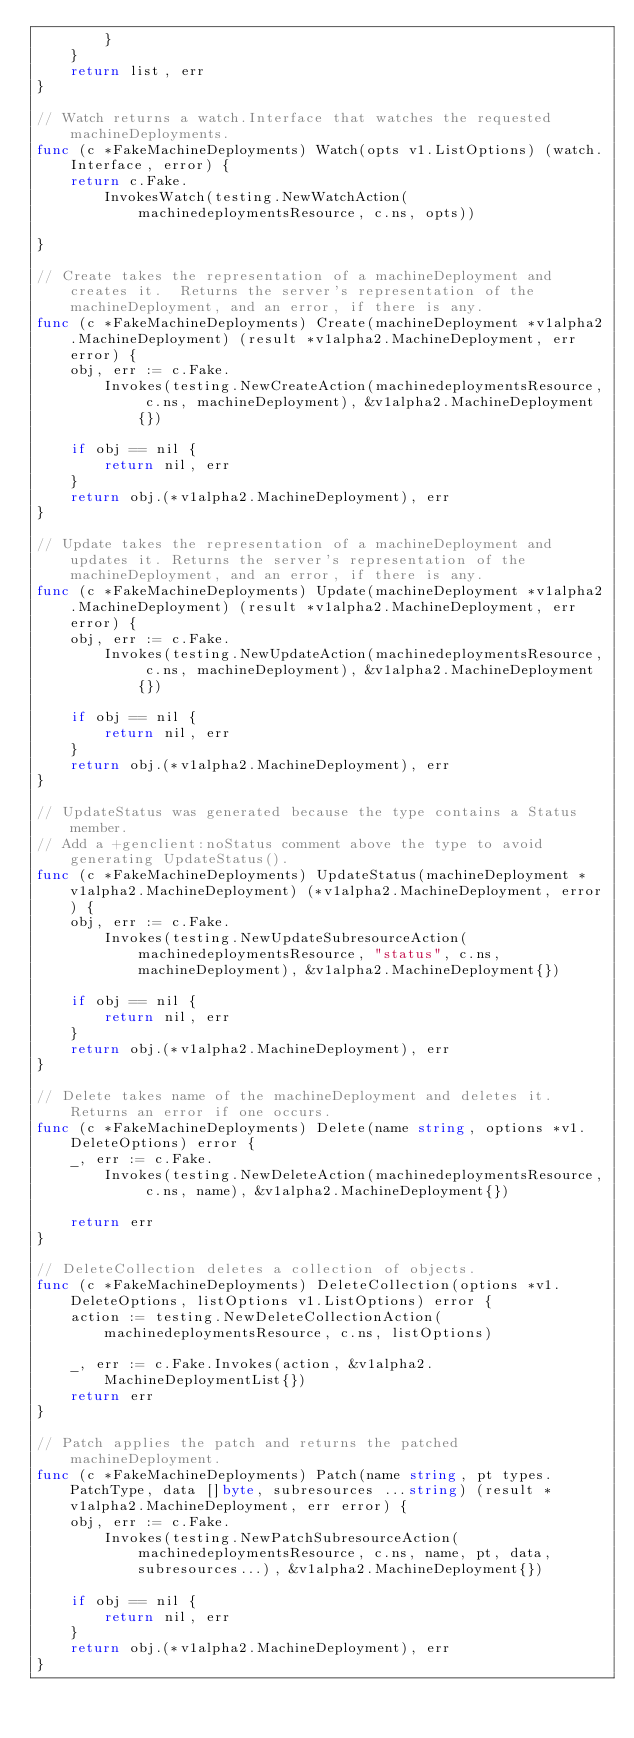Convert code to text. <code><loc_0><loc_0><loc_500><loc_500><_Go_>		}
	}
	return list, err
}

// Watch returns a watch.Interface that watches the requested machineDeployments.
func (c *FakeMachineDeployments) Watch(opts v1.ListOptions) (watch.Interface, error) {
	return c.Fake.
		InvokesWatch(testing.NewWatchAction(machinedeploymentsResource, c.ns, opts))

}

// Create takes the representation of a machineDeployment and creates it.  Returns the server's representation of the machineDeployment, and an error, if there is any.
func (c *FakeMachineDeployments) Create(machineDeployment *v1alpha2.MachineDeployment) (result *v1alpha2.MachineDeployment, err error) {
	obj, err := c.Fake.
		Invokes(testing.NewCreateAction(machinedeploymentsResource, c.ns, machineDeployment), &v1alpha2.MachineDeployment{})

	if obj == nil {
		return nil, err
	}
	return obj.(*v1alpha2.MachineDeployment), err
}

// Update takes the representation of a machineDeployment and updates it. Returns the server's representation of the machineDeployment, and an error, if there is any.
func (c *FakeMachineDeployments) Update(machineDeployment *v1alpha2.MachineDeployment) (result *v1alpha2.MachineDeployment, err error) {
	obj, err := c.Fake.
		Invokes(testing.NewUpdateAction(machinedeploymentsResource, c.ns, machineDeployment), &v1alpha2.MachineDeployment{})

	if obj == nil {
		return nil, err
	}
	return obj.(*v1alpha2.MachineDeployment), err
}

// UpdateStatus was generated because the type contains a Status member.
// Add a +genclient:noStatus comment above the type to avoid generating UpdateStatus().
func (c *FakeMachineDeployments) UpdateStatus(machineDeployment *v1alpha2.MachineDeployment) (*v1alpha2.MachineDeployment, error) {
	obj, err := c.Fake.
		Invokes(testing.NewUpdateSubresourceAction(machinedeploymentsResource, "status", c.ns, machineDeployment), &v1alpha2.MachineDeployment{})

	if obj == nil {
		return nil, err
	}
	return obj.(*v1alpha2.MachineDeployment), err
}

// Delete takes name of the machineDeployment and deletes it. Returns an error if one occurs.
func (c *FakeMachineDeployments) Delete(name string, options *v1.DeleteOptions) error {
	_, err := c.Fake.
		Invokes(testing.NewDeleteAction(machinedeploymentsResource, c.ns, name), &v1alpha2.MachineDeployment{})

	return err
}

// DeleteCollection deletes a collection of objects.
func (c *FakeMachineDeployments) DeleteCollection(options *v1.DeleteOptions, listOptions v1.ListOptions) error {
	action := testing.NewDeleteCollectionAction(machinedeploymentsResource, c.ns, listOptions)

	_, err := c.Fake.Invokes(action, &v1alpha2.MachineDeploymentList{})
	return err
}

// Patch applies the patch and returns the patched machineDeployment.
func (c *FakeMachineDeployments) Patch(name string, pt types.PatchType, data []byte, subresources ...string) (result *v1alpha2.MachineDeployment, err error) {
	obj, err := c.Fake.
		Invokes(testing.NewPatchSubresourceAction(machinedeploymentsResource, c.ns, name, pt, data, subresources...), &v1alpha2.MachineDeployment{})

	if obj == nil {
		return nil, err
	}
	return obj.(*v1alpha2.MachineDeployment), err
}
</code> 